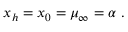Convert formula to latex. <formula><loc_0><loc_0><loc_500><loc_500>x _ { h } = x _ { 0 } = \mu _ { \infty } = \alpha \ .</formula> 